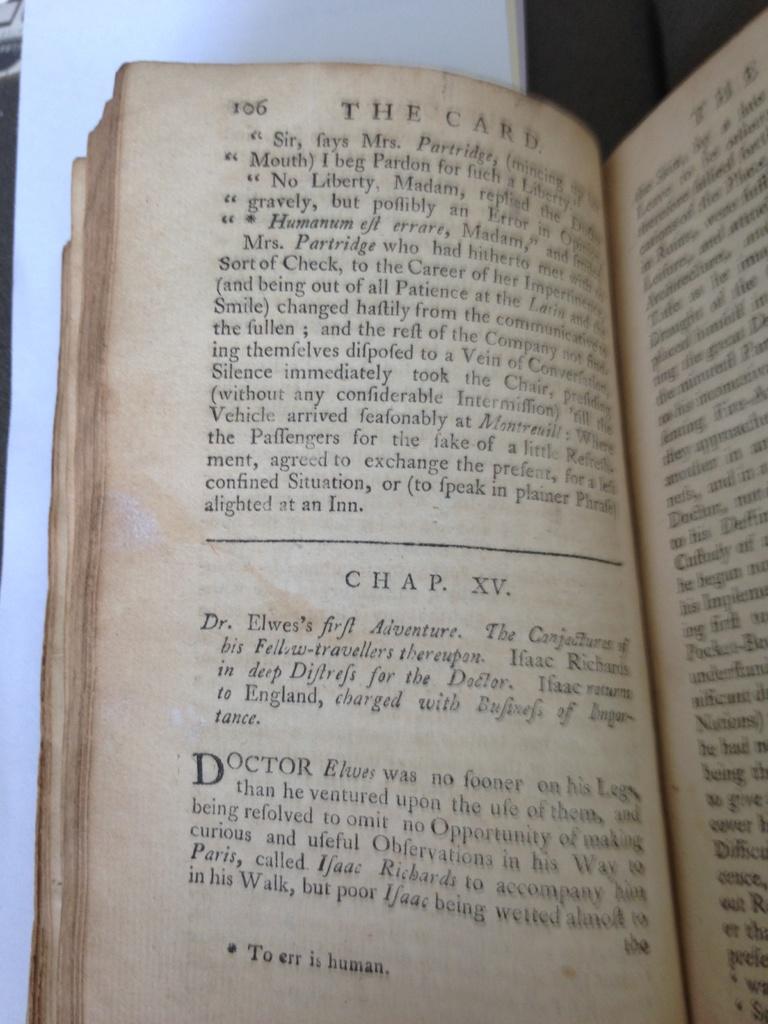What chapter is the person on?
Offer a terse response. Xv. What page is the book on?
Your response must be concise. 106. 